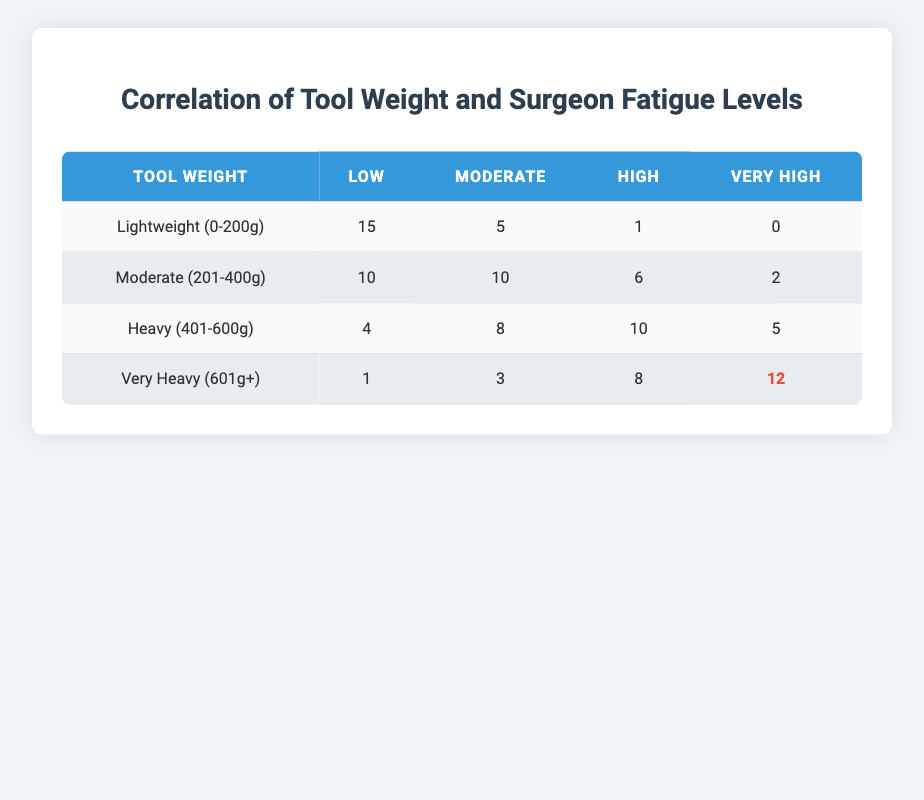What is the count of surgeons reporting low fatigue when using lightweight tools? The table shows that for lightweight tools (0-200g), the count of surgeons reporting low fatigue level is 15.
Answer: 15 What is the total count of surgeons that reported high fatigue levels across all tool weights? To find this, we sum the counts of high fatigue level for each tool weight: 1 (lightweight) + 6 (moderate) + 10 (heavy) + 8 (very heavy) = 25.
Answer: 25 Is there a surgeon reporting very high fatigue levels while using lightweight tools? According to the table, for lightweight tools (0-200g), there are 0 surgeons reporting very high fatigue levels. Therefore, the answer is no.
Answer: No Which weight category has the highest reported count of very high fatigue levels? Looking at the very high fatigue levels, only "Very Heavy (601g+)" has the highest count, which is 12. Other categories have lower counts.
Answer: Very Heavy (601g+) What is the average count of surgeons reporting moderate fatigue levels across all tool weight categories? The counts for moderate fatigue are 5 (lightweight) + 10 (moderate) + 8 (heavy) + 3 (very heavy). Summing these gives 26, and there are 4 weight categories, so the average is 26/4 = 6.5.
Answer: 6.5 How many surgeons reported low fatigue levels for heavy tools? From the table, the count of surgeons reporting low fatigue level for heavy tools (401-600g) is 4.
Answer: 4 Does any tool weight category have a count of high fatigue levels greater than 10? Yes, according to the table, the heavy tool weight (401-600g) has 10 surgeons reporting high fatigue levels, while the very heavy category has 8, which does not exceed 10. Therefore, the only category that matches is heavy but not greater.
Answer: No What is the difference in the count of surgeons reporting very high fatigue levels between heavy and very heavy weight tools? The count for heavy tool weight is 5 and for very heavy is 12. The difference calculated is 12 - 5 = 7.
Answer: 7 